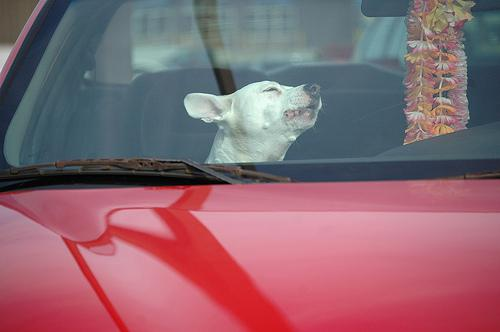Question: where was this photo taken?
Choices:
A. Outside a car with a dog in it.
B. In the bathroom.
C. At the restaurant.
D. At the beach.
Answer with the letter. Answer: A Question: where is the dog sitting?
Choices:
A. In its house.
B. On the rug.
C. Inside a car.
D. Outside.
Answer with the letter. Answer: C Question: who is the main focus of this photo?
Choices:
A. The cat.
B. The horse.
C. The sheep.
D. The dog.
Answer with the letter. Answer: D Question: what color is the car?
Choices:
A. Green.
B. White.
C. Black.
D. Red.
Answer with the letter. Answer: D 